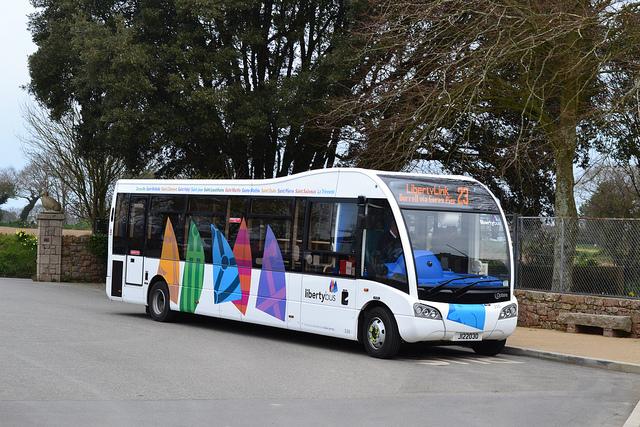Do you see number 23 on the bus?
Answer briefly. Yes. Is the bus moving?
Keep it brief. No. Is the bus in motion?
Write a very short answer. Yes. How many different colors are on the side of the bus?
Be succinct. 5. 